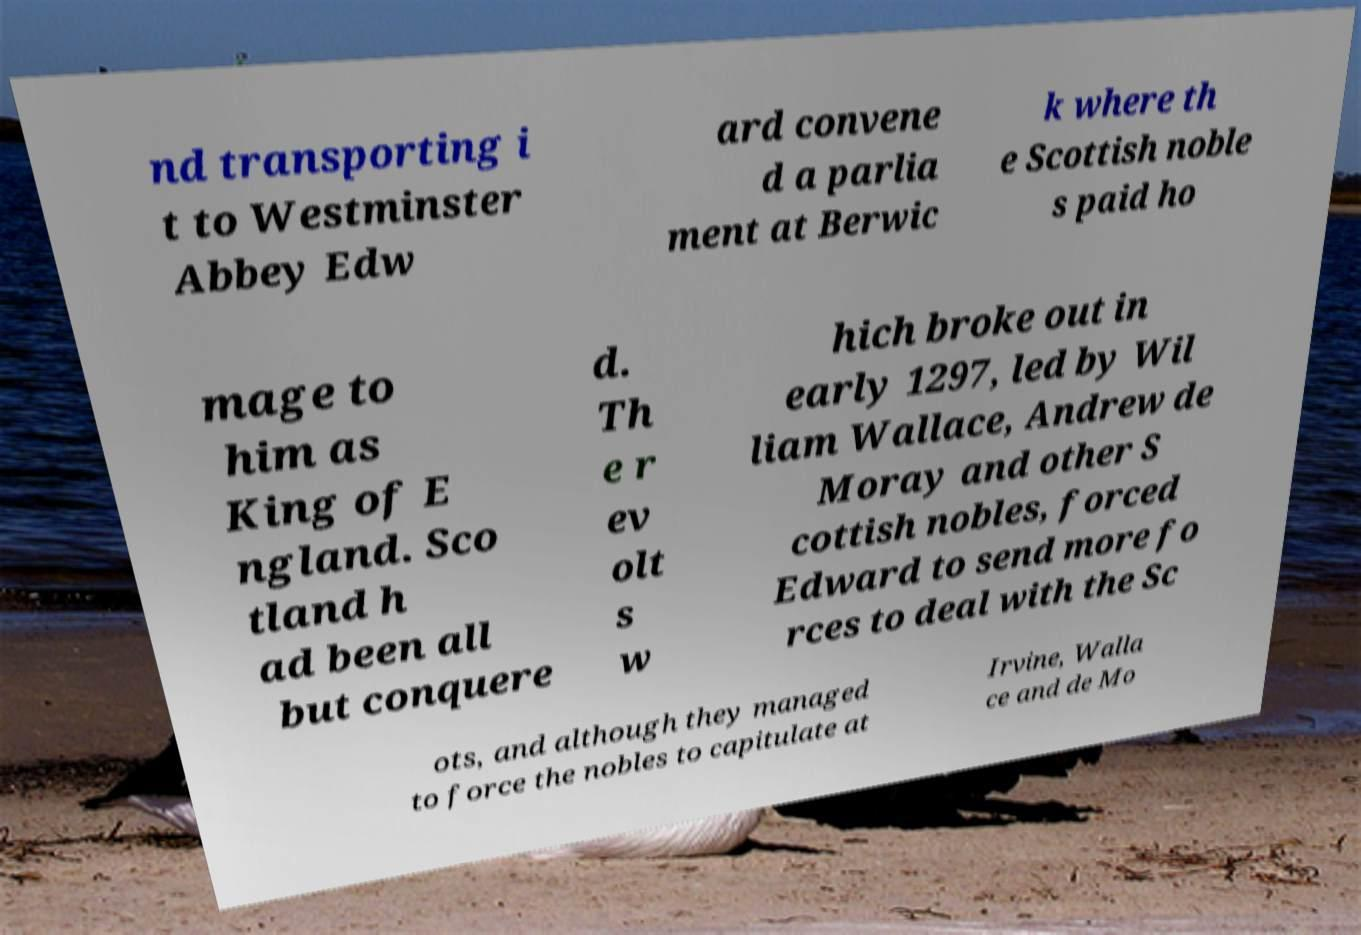Please read and relay the text visible in this image. What does it say? nd transporting i t to Westminster Abbey Edw ard convene d a parlia ment at Berwic k where th e Scottish noble s paid ho mage to him as King of E ngland. Sco tland h ad been all but conquere d. Th e r ev olt s w hich broke out in early 1297, led by Wil liam Wallace, Andrew de Moray and other S cottish nobles, forced Edward to send more fo rces to deal with the Sc ots, and although they managed to force the nobles to capitulate at Irvine, Walla ce and de Mo 